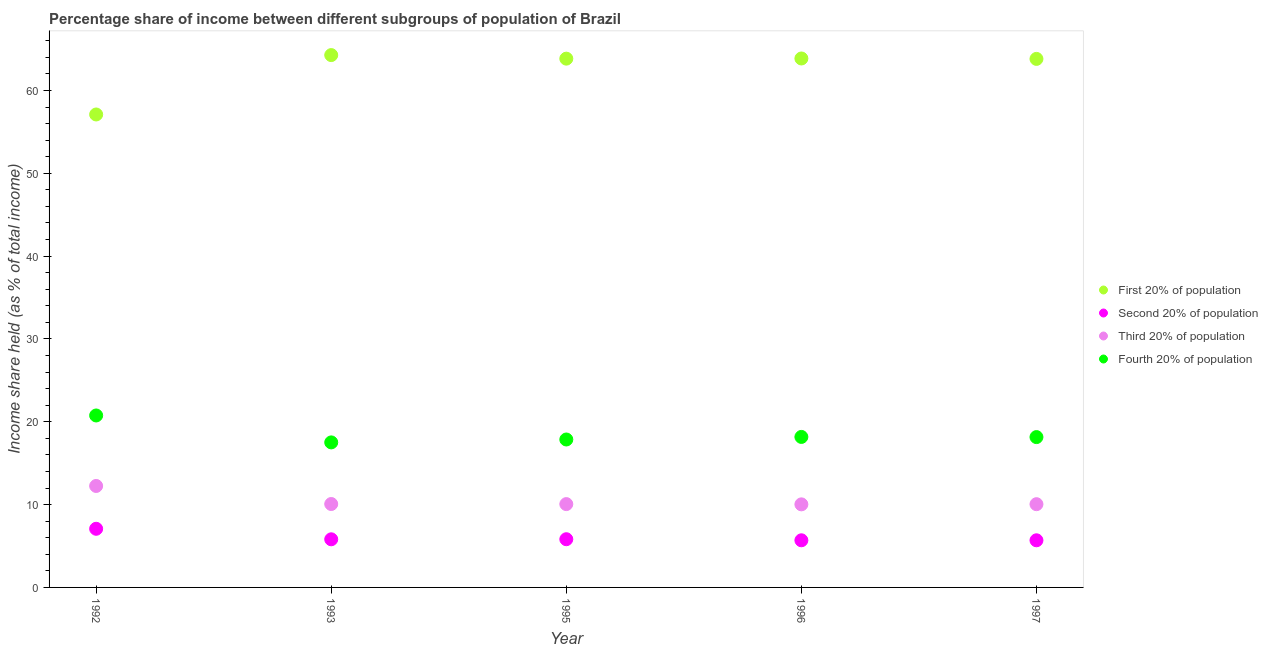How many different coloured dotlines are there?
Keep it short and to the point. 4. What is the share of the income held by first 20% of the population in 1992?
Provide a short and direct response. 57.1. Across all years, what is the maximum share of the income held by fourth 20% of the population?
Your answer should be very brief. 20.76. Across all years, what is the minimum share of the income held by third 20% of the population?
Provide a short and direct response. 10.03. In which year was the share of the income held by second 20% of the population maximum?
Give a very brief answer. 1992. What is the total share of the income held by second 20% of the population in the graph?
Your answer should be very brief. 30.09. What is the difference between the share of the income held by third 20% of the population in 1992 and that in 1995?
Offer a very short reply. 2.19. What is the difference between the share of the income held by first 20% of the population in 1993 and the share of the income held by second 20% of the population in 1996?
Your response must be concise. 58.58. What is the average share of the income held by first 20% of the population per year?
Ensure brevity in your answer.  62.58. In the year 1996, what is the difference between the share of the income held by fourth 20% of the population and share of the income held by second 20% of the population?
Ensure brevity in your answer.  12.48. What is the ratio of the share of the income held by third 20% of the population in 1992 to that in 1997?
Ensure brevity in your answer.  1.22. Is the difference between the share of the income held by fourth 20% of the population in 1992 and 1997 greater than the difference between the share of the income held by first 20% of the population in 1992 and 1997?
Your answer should be very brief. Yes. What is the difference between the highest and the second highest share of the income held by second 20% of the population?
Keep it short and to the point. 1.26. Is it the case that in every year, the sum of the share of the income held by first 20% of the population and share of the income held by second 20% of the population is greater than the share of the income held by third 20% of the population?
Make the answer very short. Yes. Is the share of the income held by first 20% of the population strictly less than the share of the income held by third 20% of the population over the years?
Ensure brevity in your answer.  No. How many dotlines are there?
Your answer should be compact. 4. How many years are there in the graph?
Your response must be concise. 5. Does the graph contain any zero values?
Ensure brevity in your answer.  No. Does the graph contain grids?
Your answer should be very brief. No. How many legend labels are there?
Make the answer very short. 4. How are the legend labels stacked?
Your answer should be compact. Vertical. What is the title of the graph?
Offer a terse response. Percentage share of income between different subgroups of population of Brazil. What is the label or title of the X-axis?
Keep it short and to the point. Year. What is the label or title of the Y-axis?
Make the answer very short. Income share held (as % of total income). What is the Income share held (as % of total income) of First 20% of population in 1992?
Your answer should be very brief. 57.1. What is the Income share held (as % of total income) in Second 20% of population in 1992?
Offer a very short reply. 7.08. What is the Income share held (as % of total income) in Third 20% of population in 1992?
Keep it short and to the point. 12.25. What is the Income share held (as % of total income) in Fourth 20% of population in 1992?
Your response must be concise. 20.76. What is the Income share held (as % of total income) of First 20% of population in 1993?
Offer a very short reply. 64.27. What is the Income share held (as % of total income) in Second 20% of population in 1993?
Offer a very short reply. 5.81. What is the Income share held (as % of total income) in Third 20% of population in 1993?
Provide a succinct answer. 10.07. What is the Income share held (as % of total income) of Fourth 20% of population in 1993?
Your response must be concise. 17.51. What is the Income share held (as % of total income) of First 20% of population in 1995?
Your answer should be very brief. 63.84. What is the Income share held (as % of total income) in Second 20% of population in 1995?
Offer a very short reply. 5.82. What is the Income share held (as % of total income) in Third 20% of population in 1995?
Ensure brevity in your answer.  10.06. What is the Income share held (as % of total income) in Fourth 20% of population in 1995?
Make the answer very short. 17.86. What is the Income share held (as % of total income) of First 20% of population in 1996?
Offer a terse response. 63.86. What is the Income share held (as % of total income) in Second 20% of population in 1996?
Offer a terse response. 5.69. What is the Income share held (as % of total income) of Third 20% of population in 1996?
Give a very brief answer. 10.03. What is the Income share held (as % of total income) of Fourth 20% of population in 1996?
Provide a succinct answer. 18.17. What is the Income share held (as % of total income) of First 20% of population in 1997?
Ensure brevity in your answer.  63.81. What is the Income share held (as % of total income) in Second 20% of population in 1997?
Offer a terse response. 5.69. What is the Income share held (as % of total income) of Third 20% of population in 1997?
Give a very brief answer. 10.05. What is the Income share held (as % of total income) of Fourth 20% of population in 1997?
Make the answer very short. 18.15. Across all years, what is the maximum Income share held (as % of total income) in First 20% of population?
Give a very brief answer. 64.27. Across all years, what is the maximum Income share held (as % of total income) in Second 20% of population?
Your response must be concise. 7.08. Across all years, what is the maximum Income share held (as % of total income) of Third 20% of population?
Give a very brief answer. 12.25. Across all years, what is the maximum Income share held (as % of total income) in Fourth 20% of population?
Provide a short and direct response. 20.76. Across all years, what is the minimum Income share held (as % of total income) in First 20% of population?
Offer a terse response. 57.1. Across all years, what is the minimum Income share held (as % of total income) of Second 20% of population?
Keep it short and to the point. 5.69. Across all years, what is the minimum Income share held (as % of total income) of Third 20% of population?
Keep it short and to the point. 10.03. Across all years, what is the minimum Income share held (as % of total income) of Fourth 20% of population?
Provide a short and direct response. 17.51. What is the total Income share held (as % of total income) of First 20% of population in the graph?
Offer a very short reply. 312.88. What is the total Income share held (as % of total income) in Second 20% of population in the graph?
Provide a short and direct response. 30.09. What is the total Income share held (as % of total income) in Third 20% of population in the graph?
Keep it short and to the point. 52.46. What is the total Income share held (as % of total income) of Fourth 20% of population in the graph?
Keep it short and to the point. 92.45. What is the difference between the Income share held (as % of total income) of First 20% of population in 1992 and that in 1993?
Your answer should be very brief. -7.17. What is the difference between the Income share held (as % of total income) in Second 20% of population in 1992 and that in 1993?
Ensure brevity in your answer.  1.27. What is the difference between the Income share held (as % of total income) of Third 20% of population in 1992 and that in 1993?
Keep it short and to the point. 2.18. What is the difference between the Income share held (as % of total income) in First 20% of population in 1992 and that in 1995?
Offer a terse response. -6.74. What is the difference between the Income share held (as % of total income) in Second 20% of population in 1992 and that in 1995?
Ensure brevity in your answer.  1.26. What is the difference between the Income share held (as % of total income) of Third 20% of population in 1992 and that in 1995?
Offer a very short reply. 2.19. What is the difference between the Income share held (as % of total income) of Fourth 20% of population in 1992 and that in 1995?
Make the answer very short. 2.9. What is the difference between the Income share held (as % of total income) in First 20% of population in 1992 and that in 1996?
Provide a succinct answer. -6.76. What is the difference between the Income share held (as % of total income) in Second 20% of population in 1992 and that in 1996?
Make the answer very short. 1.39. What is the difference between the Income share held (as % of total income) in Third 20% of population in 1992 and that in 1996?
Give a very brief answer. 2.22. What is the difference between the Income share held (as % of total income) of Fourth 20% of population in 1992 and that in 1996?
Provide a succinct answer. 2.59. What is the difference between the Income share held (as % of total income) in First 20% of population in 1992 and that in 1997?
Give a very brief answer. -6.71. What is the difference between the Income share held (as % of total income) of Second 20% of population in 1992 and that in 1997?
Give a very brief answer. 1.39. What is the difference between the Income share held (as % of total income) of Fourth 20% of population in 1992 and that in 1997?
Offer a very short reply. 2.61. What is the difference between the Income share held (as % of total income) in First 20% of population in 1993 and that in 1995?
Offer a very short reply. 0.43. What is the difference between the Income share held (as % of total income) in Second 20% of population in 1993 and that in 1995?
Provide a short and direct response. -0.01. What is the difference between the Income share held (as % of total income) in Third 20% of population in 1993 and that in 1995?
Your answer should be very brief. 0.01. What is the difference between the Income share held (as % of total income) of Fourth 20% of population in 1993 and that in 1995?
Your answer should be very brief. -0.35. What is the difference between the Income share held (as % of total income) in First 20% of population in 1993 and that in 1996?
Make the answer very short. 0.41. What is the difference between the Income share held (as % of total income) in Second 20% of population in 1993 and that in 1996?
Keep it short and to the point. 0.12. What is the difference between the Income share held (as % of total income) of Fourth 20% of population in 1993 and that in 1996?
Ensure brevity in your answer.  -0.66. What is the difference between the Income share held (as % of total income) of First 20% of population in 1993 and that in 1997?
Your answer should be compact. 0.46. What is the difference between the Income share held (as % of total income) in Second 20% of population in 1993 and that in 1997?
Your answer should be compact. 0.12. What is the difference between the Income share held (as % of total income) in Third 20% of population in 1993 and that in 1997?
Your response must be concise. 0.02. What is the difference between the Income share held (as % of total income) in Fourth 20% of population in 1993 and that in 1997?
Ensure brevity in your answer.  -0.64. What is the difference between the Income share held (as % of total income) of First 20% of population in 1995 and that in 1996?
Make the answer very short. -0.02. What is the difference between the Income share held (as % of total income) of Second 20% of population in 1995 and that in 1996?
Your answer should be compact. 0.13. What is the difference between the Income share held (as % of total income) in Fourth 20% of population in 1995 and that in 1996?
Ensure brevity in your answer.  -0.31. What is the difference between the Income share held (as % of total income) of First 20% of population in 1995 and that in 1997?
Your response must be concise. 0.03. What is the difference between the Income share held (as % of total income) in Second 20% of population in 1995 and that in 1997?
Keep it short and to the point. 0.13. What is the difference between the Income share held (as % of total income) in Third 20% of population in 1995 and that in 1997?
Provide a short and direct response. 0.01. What is the difference between the Income share held (as % of total income) in Fourth 20% of population in 1995 and that in 1997?
Ensure brevity in your answer.  -0.29. What is the difference between the Income share held (as % of total income) of First 20% of population in 1996 and that in 1997?
Make the answer very short. 0.05. What is the difference between the Income share held (as % of total income) in Second 20% of population in 1996 and that in 1997?
Your answer should be very brief. 0. What is the difference between the Income share held (as % of total income) of Third 20% of population in 1996 and that in 1997?
Provide a succinct answer. -0.02. What is the difference between the Income share held (as % of total income) of Fourth 20% of population in 1996 and that in 1997?
Your response must be concise. 0.02. What is the difference between the Income share held (as % of total income) in First 20% of population in 1992 and the Income share held (as % of total income) in Second 20% of population in 1993?
Offer a very short reply. 51.29. What is the difference between the Income share held (as % of total income) of First 20% of population in 1992 and the Income share held (as % of total income) of Third 20% of population in 1993?
Offer a very short reply. 47.03. What is the difference between the Income share held (as % of total income) in First 20% of population in 1992 and the Income share held (as % of total income) in Fourth 20% of population in 1993?
Make the answer very short. 39.59. What is the difference between the Income share held (as % of total income) of Second 20% of population in 1992 and the Income share held (as % of total income) of Third 20% of population in 1993?
Keep it short and to the point. -2.99. What is the difference between the Income share held (as % of total income) in Second 20% of population in 1992 and the Income share held (as % of total income) in Fourth 20% of population in 1993?
Your answer should be very brief. -10.43. What is the difference between the Income share held (as % of total income) in Third 20% of population in 1992 and the Income share held (as % of total income) in Fourth 20% of population in 1993?
Your answer should be very brief. -5.26. What is the difference between the Income share held (as % of total income) in First 20% of population in 1992 and the Income share held (as % of total income) in Second 20% of population in 1995?
Your answer should be compact. 51.28. What is the difference between the Income share held (as % of total income) of First 20% of population in 1992 and the Income share held (as % of total income) of Third 20% of population in 1995?
Give a very brief answer. 47.04. What is the difference between the Income share held (as % of total income) in First 20% of population in 1992 and the Income share held (as % of total income) in Fourth 20% of population in 1995?
Keep it short and to the point. 39.24. What is the difference between the Income share held (as % of total income) of Second 20% of population in 1992 and the Income share held (as % of total income) of Third 20% of population in 1995?
Your response must be concise. -2.98. What is the difference between the Income share held (as % of total income) of Second 20% of population in 1992 and the Income share held (as % of total income) of Fourth 20% of population in 1995?
Provide a succinct answer. -10.78. What is the difference between the Income share held (as % of total income) of Third 20% of population in 1992 and the Income share held (as % of total income) of Fourth 20% of population in 1995?
Your answer should be very brief. -5.61. What is the difference between the Income share held (as % of total income) in First 20% of population in 1992 and the Income share held (as % of total income) in Second 20% of population in 1996?
Your response must be concise. 51.41. What is the difference between the Income share held (as % of total income) of First 20% of population in 1992 and the Income share held (as % of total income) of Third 20% of population in 1996?
Make the answer very short. 47.07. What is the difference between the Income share held (as % of total income) of First 20% of population in 1992 and the Income share held (as % of total income) of Fourth 20% of population in 1996?
Keep it short and to the point. 38.93. What is the difference between the Income share held (as % of total income) in Second 20% of population in 1992 and the Income share held (as % of total income) in Third 20% of population in 1996?
Make the answer very short. -2.95. What is the difference between the Income share held (as % of total income) in Second 20% of population in 1992 and the Income share held (as % of total income) in Fourth 20% of population in 1996?
Make the answer very short. -11.09. What is the difference between the Income share held (as % of total income) in Third 20% of population in 1992 and the Income share held (as % of total income) in Fourth 20% of population in 1996?
Your response must be concise. -5.92. What is the difference between the Income share held (as % of total income) in First 20% of population in 1992 and the Income share held (as % of total income) in Second 20% of population in 1997?
Provide a succinct answer. 51.41. What is the difference between the Income share held (as % of total income) in First 20% of population in 1992 and the Income share held (as % of total income) in Third 20% of population in 1997?
Offer a very short reply. 47.05. What is the difference between the Income share held (as % of total income) in First 20% of population in 1992 and the Income share held (as % of total income) in Fourth 20% of population in 1997?
Provide a short and direct response. 38.95. What is the difference between the Income share held (as % of total income) of Second 20% of population in 1992 and the Income share held (as % of total income) of Third 20% of population in 1997?
Give a very brief answer. -2.97. What is the difference between the Income share held (as % of total income) in Second 20% of population in 1992 and the Income share held (as % of total income) in Fourth 20% of population in 1997?
Keep it short and to the point. -11.07. What is the difference between the Income share held (as % of total income) of Third 20% of population in 1992 and the Income share held (as % of total income) of Fourth 20% of population in 1997?
Provide a succinct answer. -5.9. What is the difference between the Income share held (as % of total income) in First 20% of population in 1993 and the Income share held (as % of total income) in Second 20% of population in 1995?
Keep it short and to the point. 58.45. What is the difference between the Income share held (as % of total income) of First 20% of population in 1993 and the Income share held (as % of total income) of Third 20% of population in 1995?
Offer a very short reply. 54.21. What is the difference between the Income share held (as % of total income) in First 20% of population in 1993 and the Income share held (as % of total income) in Fourth 20% of population in 1995?
Offer a terse response. 46.41. What is the difference between the Income share held (as % of total income) in Second 20% of population in 1993 and the Income share held (as % of total income) in Third 20% of population in 1995?
Your answer should be compact. -4.25. What is the difference between the Income share held (as % of total income) of Second 20% of population in 1993 and the Income share held (as % of total income) of Fourth 20% of population in 1995?
Provide a succinct answer. -12.05. What is the difference between the Income share held (as % of total income) in Third 20% of population in 1993 and the Income share held (as % of total income) in Fourth 20% of population in 1995?
Your answer should be compact. -7.79. What is the difference between the Income share held (as % of total income) in First 20% of population in 1993 and the Income share held (as % of total income) in Second 20% of population in 1996?
Offer a very short reply. 58.58. What is the difference between the Income share held (as % of total income) in First 20% of population in 1993 and the Income share held (as % of total income) in Third 20% of population in 1996?
Give a very brief answer. 54.24. What is the difference between the Income share held (as % of total income) of First 20% of population in 1993 and the Income share held (as % of total income) of Fourth 20% of population in 1996?
Make the answer very short. 46.1. What is the difference between the Income share held (as % of total income) in Second 20% of population in 1993 and the Income share held (as % of total income) in Third 20% of population in 1996?
Offer a terse response. -4.22. What is the difference between the Income share held (as % of total income) of Second 20% of population in 1993 and the Income share held (as % of total income) of Fourth 20% of population in 1996?
Provide a short and direct response. -12.36. What is the difference between the Income share held (as % of total income) of Third 20% of population in 1993 and the Income share held (as % of total income) of Fourth 20% of population in 1996?
Make the answer very short. -8.1. What is the difference between the Income share held (as % of total income) of First 20% of population in 1993 and the Income share held (as % of total income) of Second 20% of population in 1997?
Offer a terse response. 58.58. What is the difference between the Income share held (as % of total income) in First 20% of population in 1993 and the Income share held (as % of total income) in Third 20% of population in 1997?
Your response must be concise. 54.22. What is the difference between the Income share held (as % of total income) of First 20% of population in 1993 and the Income share held (as % of total income) of Fourth 20% of population in 1997?
Keep it short and to the point. 46.12. What is the difference between the Income share held (as % of total income) in Second 20% of population in 1993 and the Income share held (as % of total income) in Third 20% of population in 1997?
Ensure brevity in your answer.  -4.24. What is the difference between the Income share held (as % of total income) in Second 20% of population in 1993 and the Income share held (as % of total income) in Fourth 20% of population in 1997?
Make the answer very short. -12.34. What is the difference between the Income share held (as % of total income) in Third 20% of population in 1993 and the Income share held (as % of total income) in Fourth 20% of population in 1997?
Your answer should be compact. -8.08. What is the difference between the Income share held (as % of total income) of First 20% of population in 1995 and the Income share held (as % of total income) of Second 20% of population in 1996?
Ensure brevity in your answer.  58.15. What is the difference between the Income share held (as % of total income) of First 20% of population in 1995 and the Income share held (as % of total income) of Third 20% of population in 1996?
Offer a terse response. 53.81. What is the difference between the Income share held (as % of total income) of First 20% of population in 1995 and the Income share held (as % of total income) of Fourth 20% of population in 1996?
Your response must be concise. 45.67. What is the difference between the Income share held (as % of total income) in Second 20% of population in 1995 and the Income share held (as % of total income) in Third 20% of population in 1996?
Keep it short and to the point. -4.21. What is the difference between the Income share held (as % of total income) of Second 20% of population in 1995 and the Income share held (as % of total income) of Fourth 20% of population in 1996?
Offer a terse response. -12.35. What is the difference between the Income share held (as % of total income) in Third 20% of population in 1995 and the Income share held (as % of total income) in Fourth 20% of population in 1996?
Ensure brevity in your answer.  -8.11. What is the difference between the Income share held (as % of total income) of First 20% of population in 1995 and the Income share held (as % of total income) of Second 20% of population in 1997?
Your response must be concise. 58.15. What is the difference between the Income share held (as % of total income) in First 20% of population in 1995 and the Income share held (as % of total income) in Third 20% of population in 1997?
Offer a very short reply. 53.79. What is the difference between the Income share held (as % of total income) in First 20% of population in 1995 and the Income share held (as % of total income) in Fourth 20% of population in 1997?
Your response must be concise. 45.69. What is the difference between the Income share held (as % of total income) in Second 20% of population in 1995 and the Income share held (as % of total income) in Third 20% of population in 1997?
Provide a succinct answer. -4.23. What is the difference between the Income share held (as % of total income) of Second 20% of population in 1995 and the Income share held (as % of total income) of Fourth 20% of population in 1997?
Ensure brevity in your answer.  -12.33. What is the difference between the Income share held (as % of total income) of Third 20% of population in 1995 and the Income share held (as % of total income) of Fourth 20% of population in 1997?
Give a very brief answer. -8.09. What is the difference between the Income share held (as % of total income) of First 20% of population in 1996 and the Income share held (as % of total income) of Second 20% of population in 1997?
Offer a very short reply. 58.17. What is the difference between the Income share held (as % of total income) of First 20% of population in 1996 and the Income share held (as % of total income) of Third 20% of population in 1997?
Your answer should be very brief. 53.81. What is the difference between the Income share held (as % of total income) in First 20% of population in 1996 and the Income share held (as % of total income) in Fourth 20% of population in 1997?
Your answer should be very brief. 45.71. What is the difference between the Income share held (as % of total income) of Second 20% of population in 1996 and the Income share held (as % of total income) of Third 20% of population in 1997?
Your answer should be very brief. -4.36. What is the difference between the Income share held (as % of total income) of Second 20% of population in 1996 and the Income share held (as % of total income) of Fourth 20% of population in 1997?
Make the answer very short. -12.46. What is the difference between the Income share held (as % of total income) in Third 20% of population in 1996 and the Income share held (as % of total income) in Fourth 20% of population in 1997?
Ensure brevity in your answer.  -8.12. What is the average Income share held (as % of total income) in First 20% of population per year?
Offer a very short reply. 62.58. What is the average Income share held (as % of total income) of Second 20% of population per year?
Offer a terse response. 6.02. What is the average Income share held (as % of total income) of Third 20% of population per year?
Keep it short and to the point. 10.49. What is the average Income share held (as % of total income) of Fourth 20% of population per year?
Your response must be concise. 18.49. In the year 1992, what is the difference between the Income share held (as % of total income) in First 20% of population and Income share held (as % of total income) in Second 20% of population?
Give a very brief answer. 50.02. In the year 1992, what is the difference between the Income share held (as % of total income) in First 20% of population and Income share held (as % of total income) in Third 20% of population?
Make the answer very short. 44.85. In the year 1992, what is the difference between the Income share held (as % of total income) of First 20% of population and Income share held (as % of total income) of Fourth 20% of population?
Provide a succinct answer. 36.34. In the year 1992, what is the difference between the Income share held (as % of total income) of Second 20% of population and Income share held (as % of total income) of Third 20% of population?
Your response must be concise. -5.17. In the year 1992, what is the difference between the Income share held (as % of total income) of Second 20% of population and Income share held (as % of total income) of Fourth 20% of population?
Your answer should be compact. -13.68. In the year 1992, what is the difference between the Income share held (as % of total income) in Third 20% of population and Income share held (as % of total income) in Fourth 20% of population?
Offer a terse response. -8.51. In the year 1993, what is the difference between the Income share held (as % of total income) in First 20% of population and Income share held (as % of total income) in Second 20% of population?
Offer a very short reply. 58.46. In the year 1993, what is the difference between the Income share held (as % of total income) in First 20% of population and Income share held (as % of total income) in Third 20% of population?
Offer a terse response. 54.2. In the year 1993, what is the difference between the Income share held (as % of total income) of First 20% of population and Income share held (as % of total income) of Fourth 20% of population?
Ensure brevity in your answer.  46.76. In the year 1993, what is the difference between the Income share held (as % of total income) of Second 20% of population and Income share held (as % of total income) of Third 20% of population?
Make the answer very short. -4.26. In the year 1993, what is the difference between the Income share held (as % of total income) of Second 20% of population and Income share held (as % of total income) of Fourth 20% of population?
Make the answer very short. -11.7. In the year 1993, what is the difference between the Income share held (as % of total income) in Third 20% of population and Income share held (as % of total income) in Fourth 20% of population?
Your answer should be compact. -7.44. In the year 1995, what is the difference between the Income share held (as % of total income) in First 20% of population and Income share held (as % of total income) in Second 20% of population?
Keep it short and to the point. 58.02. In the year 1995, what is the difference between the Income share held (as % of total income) in First 20% of population and Income share held (as % of total income) in Third 20% of population?
Give a very brief answer. 53.78. In the year 1995, what is the difference between the Income share held (as % of total income) in First 20% of population and Income share held (as % of total income) in Fourth 20% of population?
Make the answer very short. 45.98. In the year 1995, what is the difference between the Income share held (as % of total income) in Second 20% of population and Income share held (as % of total income) in Third 20% of population?
Offer a terse response. -4.24. In the year 1995, what is the difference between the Income share held (as % of total income) in Second 20% of population and Income share held (as % of total income) in Fourth 20% of population?
Offer a terse response. -12.04. In the year 1996, what is the difference between the Income share held (as % of total income) of First 20% of population and Income share held (as % of total income) of Second 20% of population?
Provide a short and direct response. 58.17. In the year 1996, what is the difference between the Income share held (as % of total income) in First 20% of population and Income share held (as % of total income) in Third 20% of population?
Keep it short and to the point. 53.83. In the year 1996, what is the difference between the Income share held (as % of total income) in First 20% of population and Income share held (as % of total income) in Fourth 20% of population?
Your answer should be compact. 45.69. In the year 1996, what is the difference between the Income share held (as % of total income) in Second 20% of population and Income share held (as % of total income) in Third 20% of population?
Give a very brief answer. -4.34. In the year 1996, what is the difference between the Income share held (as % of total income) of Second 20% of population and Income share held (as % of total income) of Fourth 20% of population?
Ensure brevity in your answer.  -12.48. In the year 1996, what is the difference between the Income share held (as % of total income) of Third 20% of population and Income share held (as % of total income) of Fourth 20% of population?
Provide a short and direct response. -8.14. In the year 1997, what is the difference between the Income share held (as % of total income) in First 20% of population and Income share held (as % of total income) in Second 20% of population?
Your response must be concise. 58.12. In the year 1997, what is the difference between the Income share held (as % of total income) of First 20% of population and Income share held (as % of total income) of Third 20% of population?
Make the answer very short. 53.76. In the year 1997, what is the difference between the Income share held (as % of total income) in First 20% of population and Income share held (as % of total income) in Fourth 20% of population?
Your answer should be compact. 45.66. In the year 1997, what is the difference between the Income share held (as % of total income) of Second 20% of population and Income share held (as % of total income) of Third 20% of population?
Offer a very short reply. -4.36. In the year 1997, what is the difference between the Income share held (as % of total income) of Second 20% of population and Income share held (as % of total income) of Fourth 20% of population?
Provide a succinct answer. -12.46. In the year 1997, what is the difference between the Income share held (as % of total income) of Third 20% of population and Income share held (as % of total income) of Fourth 20% of population?
Your answer should be very brief. -8.1. What is the ratio of the Income share held (as % of total income) of First 20% of population in 1992 to that in 1993?
Your answer should be compact. 0.89. What is the ratio of the Income share held (as % of total income) of Second 20% of population in 1992 to that in 1993?
Provide a short and direct response. 1.22. What is the ratio of the Income share held (as % of total income) in Third 20% of population in 1992 to that in 1993?
Keep it short and to the point. 1.22. What is the ratio of the Income share held (as % of total income) in Fourth 20% of population in 1992 to that in 1993?
Offer a very short reply. 1.19. What is the ratio of the Income share held (as % of total income) of First 20% of population in 1992 to that in 1995?
Offer a terse response. 0.89. What is the ratio of the Income share held (as % of total income) of Second 20% of population in 1992 to that in 1995?
Your response must be concise. 1.22. What is the ratio of the Income share held (as % of total income) in Third 20% of population in 1992 to that in 1995?
Offer a terse response. 1.22. What is the ratio of the Income share held (as % of total income) in Fourth 20% of population in 1992 to that in 1995?
Offer a terse response. 1.16. What is the ratio of the Income share held (as % of total income) of First 20% of population in 1992 to that in 1996?
Offer a terse response. 0.89. What is the ratio of the Income share held (as % of total income) of Second 20% of population in 1992 to that in 1996?
Your response must be concise. 1.24. What is the ratio of the Income share held (as % of total income) in Third 20% of population in 1992 to that in 1996?
Give a very brief answer. 1.22. What is the ratio of the Income share held (as % of total income) of Fourth 20% of population in 1992 to that in 1996?
Give a very brief answer. 1.14. What is the ratio of the Income share held (as % of total income) of First 20% of population in 1992 to that in 1997?
Keep it short and to the point. 0.89. What is the ratio of the Income share held (as % of total income) in Second 20% of population in 1992 to that in 1997?
Your answer should be very brief. 1.24. What is the ratio of the Income share held (as % of total income) in Third 20% of population in 1992 to that in 1997?
Provide a short and direct response. 1.22. What is the ratio of the Income share held (as % of total income) of Fourth 20% of population in 1992 to that in 1997?
Provide a succinct answer. 1.14. What is the ratio of the Income share held (as % of total income) of First 20% of population in 1993 to that in 1995?
Keep it short and to the point. 1.01. What is the ratio of the Income share held (as % of total income) in Second 20% of population in 1993 to that in 1995?
Keep it short and to the point. 1. What is the ratio of the Income share held (as % of total income) in Third 20% of population in 1993 to that in 1995?
Keep it short and to the point. 1. What is the ratio of the Income share held (as % of total income) of Fourth 20% of population in 1993 to that in 1995?
Offer a very short reply. 0.98. What is the ratio of the Income share held (as % of total income) of First 20% of population in 1993 to that in 1996?
Make the answer very short. 1.01. What is the ratio of the Income share held (as % of total income) in Second 20% of population in 1993 to that in 1996?
Provide a short and direct response. 1.02. What is the ratio of the Income share held (as % of total income) in Third 20% of population in 1993 to that in 1996?
Offer a very short reply. 1. What is the ratio of the Income share held (as % of total income) in Fourth 20% of population in 1993 to that in 1996?
Keep it short and to the point. 0.96. What is the ratio of the Income share held (as % of total income) of Second 20% of population in 1993 to that in 1997?
Your answer should be very brief. 1.02. What is the ratio of the Income share held (as % of total income) in Third 20% of population in 1993 to that in 1997?
Provide a succinct answer. 1. What is the ratio of the Income share held (as % of total income) of Fourth 20% of population in 1993 to that in 1997?
Offer a terse response. 0.96. What is the ratio of the Income share held (as % of total income) in Second 20% of population in 1995 to that in 1996?
Provide a short and direct response. 1.02. What is the ratio of the Income share held (as % of total income) in Fourth 20% of population in 1995 to that in 1996?
Ensure brevity in your answer.  0.98. What is the ratio of the Income share held (as % of total income) in First 20% of population in 1995 to that in 1997?
Keep it short and to the point. 1. What is the ratio of the Income share held (as % of total income) in Second 20% of population in 1995 to that in 1997?
Offer a very short reply. 1.02. What is the ratio of the Income share held (as % of total income) of Third 20% of population in 1995 to that in 1997?
Your response must be concise. 1. What is the ratio of the Income share held (as % of total income) of Fourth 20% of population in 1995 to that in 1997?
Ensure brevity in your answer.  0.98. What is the ratio of the Income share held (as % of total income) in Third 20% of population in 1996 to that in 1997?
Keep it short and to the point. 1. What is the ratio of the Income share held (as % of total income) in Fourth 20% of population in 1996 to that in 1997?
Offer a very short reply. 1. What is the difference between the highest and the second highest Income share held (as % of total income) in First 20% of population?
Keep it short and to the point. 0.41. What is the difference between the highest and the second highest Income share held (as % of total income) in Second 20% of population?
Ensure brevity in your answer.  1.26. What is the difference between the highest and the second highest Income share held (as % of total income) in Third 20% of population?
Provide a short and direct response. 2.18. What is the difference between the highest and the second highest Income share held (as % of total income) of Fourth 20% of population?
Provide a succinct answer. 2.59. What is the difference between the highest and the lowest Income share held (as % of total income) in First 20% of population?
Ensure brevity in your answer.  7.17. What is the difference between the highest and the lowest Income share held (as % of total income) of Second 20% of population?
Offer a terse response. 1.39. What is the difference between the highest and the lowest Income share held (as % of total income) in Third 20% of population?
Give a very brief answer. 2.22. 